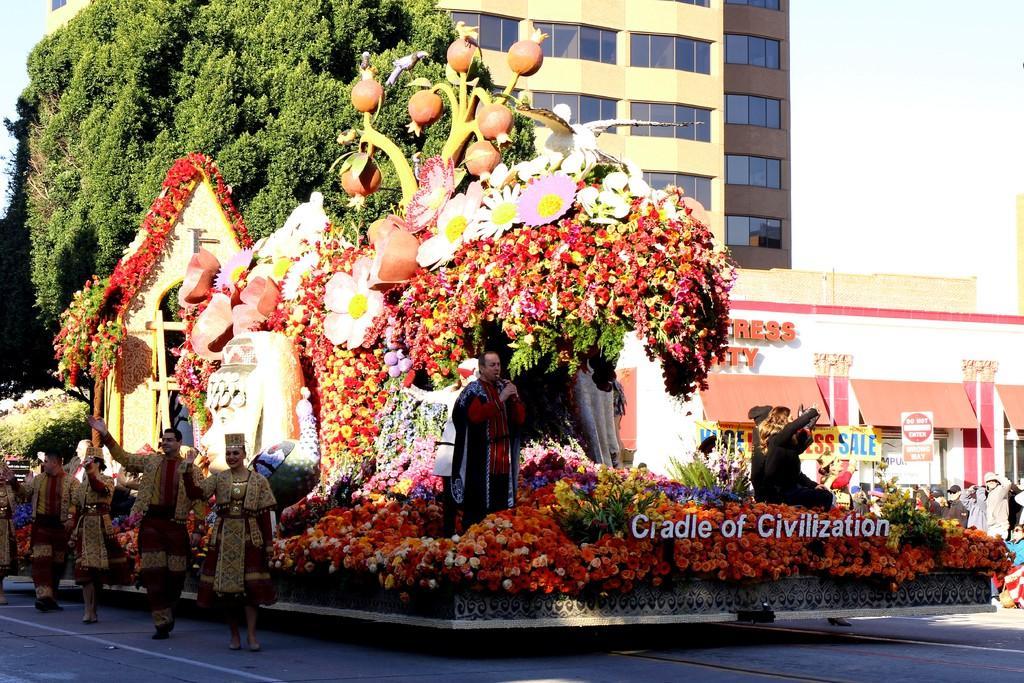Please provide a concise description of this image. In this image there is a person standing and holding a mic is speaking, the person is surrounded by flowers decorated on a vehicle, beside the person there are four people walking on the road and waving the hand, in the background of the image there are trees and buildings and there is a name plate in front of the vehicle. 